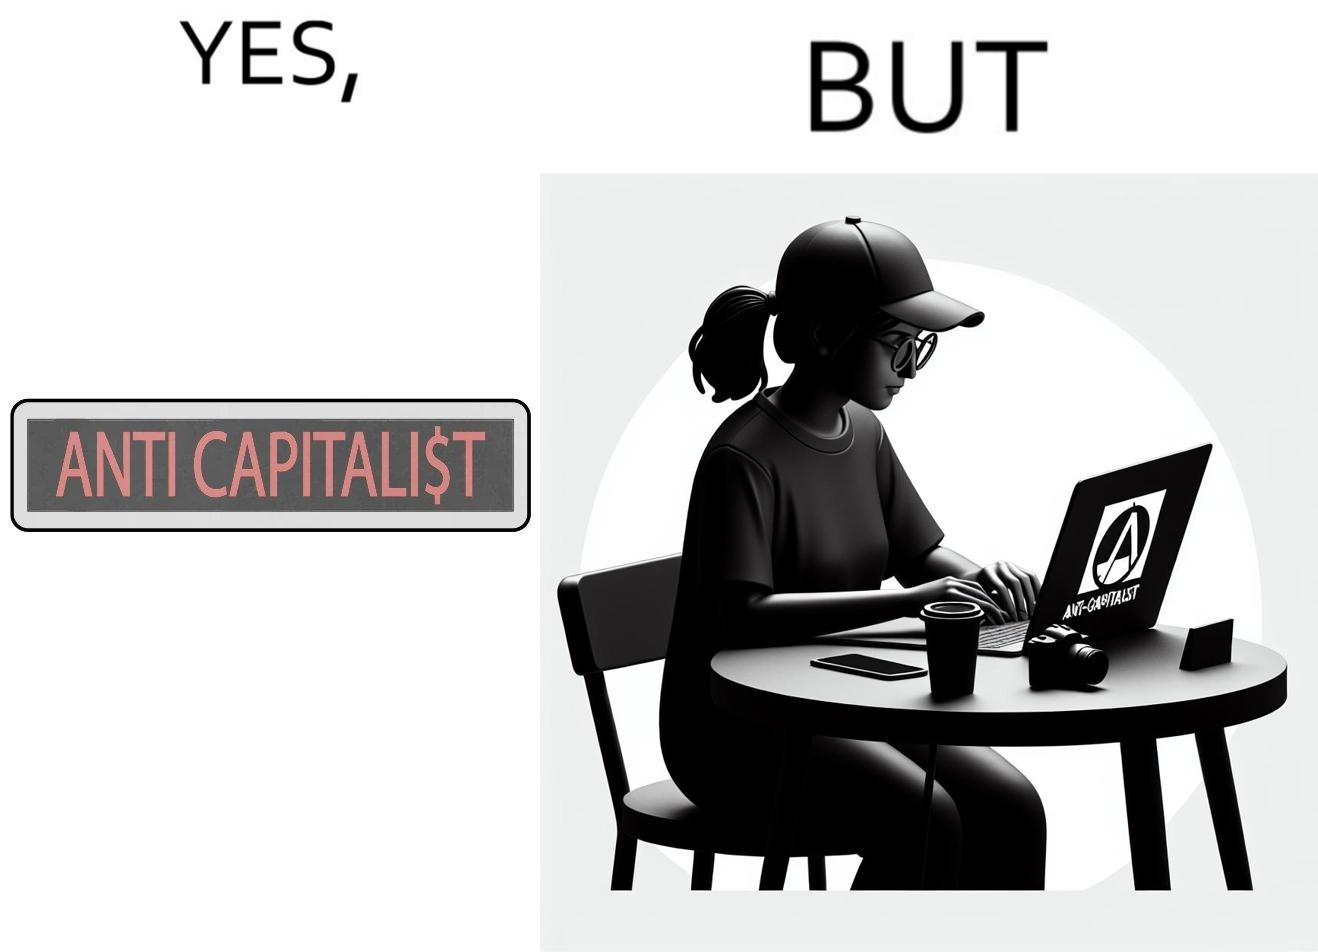Provide a description of this image. The overall image is ironical because the people who claim to be anticapitalist are the ones with a lot of capital as shown here. While the woman supports anticapitalism as shown by the sticker on the back of her laptop, she has a phone, a camera and a laptop all of which require money. 